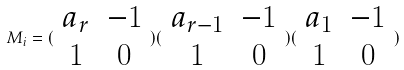<formula> <loc_0><loc_0><loc_500><loc_500>M _ { i } = ( \begin{array} { c c } a _ { r } & - 1 \\ 1 & 0 \end{array} ) ( \begin{array} { c c } a _ { r - 1 } & - 1 \\ 1 & 0 \end{array} ) ( \begin{array} { c c } a _ { 1 } & - 1 \\ 1 & 0 \end{array} )</formula> 